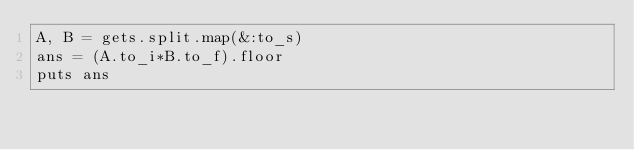Convert code to text. <code><loc_0><loc_0><loc_500><loc_500><_Ruby_>A, B = gets.split.map(&:to_s)
ans = (A.to_i*B.to_f).floor
puts ans</code> 